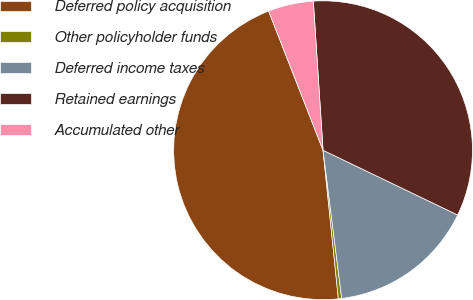Convert chart. <chart><loc_0><loc_0><loc_500><loc_500><pie_chart><fcel>Deferred policy acquisition<fcel>Other policyholder funds<fcel>Deferred income taxes<fcel>Retained earnings<fcel>Accumulated other<nl><fcel>45.7%<fcel>0.36%<fcel>15.87%<fcel>33.17%<fcel>4.9%<nl></chart> 